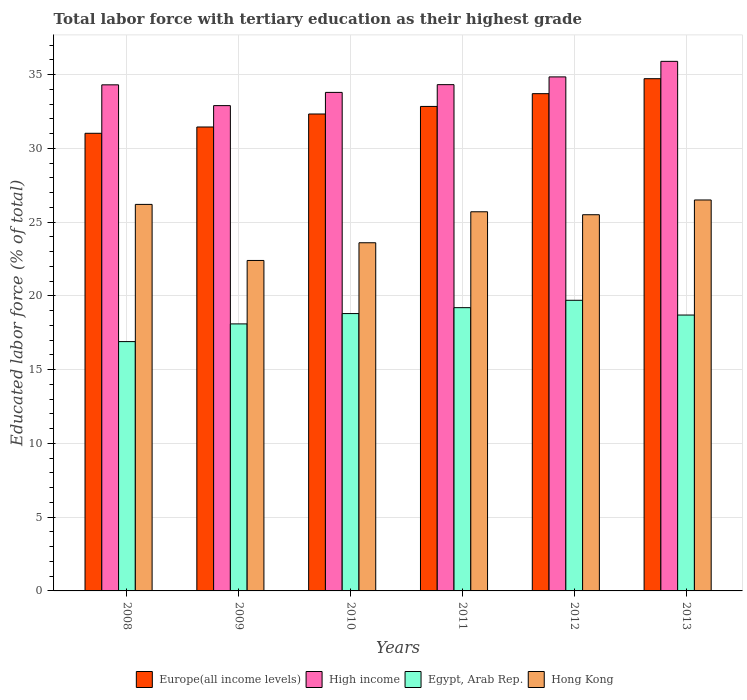How many groups of bars are there?
Offer a terse response. 6. Are the number of bars on each tick of the X-axis equal?
Ensure brevity in your answer.  Yes. What is the label of the 2nd group of bars from the left?
Ensure brevity in your answer.  2009. In how many cases, is the number of bars for a given year not equal to the number of legend labels?
Your answer should be very brief. 0. What is the percentage of male labor force with tertiary education in High income in 2012?
Provide a succinct answer. 34.84. Across all years, what is the maximum percentage of male labor force with tertiary education in Hong Kong?
Provide a short and direct response. 26.5. Across all years, what is the minimum percentage of male labor force with tertiary education in High income?
Your response must be concise. 32.9. In which year was the percentage of male labor force with tertiary education in Hong Kong minimum?
Keep it short and to the point. 2009. What is the total percentage of male labor force with tertiary education in Europe(all income levels) in the graph?
Give a very brief answer. 196.06. What is the difference between the percentage of male labor force with tertiary education in Europe(all income levels) in 2009 and that in 2010?
Provide a short and direct response. -0.88. What is the difference between the percentage of male labor force with tertiary education in High income in 2011 and the percentage of male labor force with tertiary education in Egypt, Arab Rep. in 2008?
Your answer should be very brief. 17.42. What is the average percentage of male labor force with tertiary education in High income per year?
Provide a short and direct response. 34.34. In the year 2011, what is the difference between the percentage of male labor force with tertiary education in Hong Kong and percentage of male labor force with tertiary education in Egypt, Arab Rep.?
Keep it short and to the point. 6.5. What is the ratio of the percentage of male labor force with tertiary education in Europe(all income levels) in 2009 to that in 2011?
Provide a succinct answer. 0.96. Is the percentage of male labor force with tertiary education in Europe(all income levels) in 2009 less than that in 2010?
Offer a terse response. Yes. What is the difference between the highest and the second highest percentage of male labor force with tertiary education in High income?
Your response must be concise. 1.05. What is the difference between the highest and the lowest percentage of male labor force with tertiary education in Egypt, Arab Rep.?
Offer a terse response. 2.8. Is the sum of the percentage of male labor force with tertiary education in Hong Kong in 2009 and 2012 greater than the maximum percentage of male labor force with tertiary education in Egypt, Arab Rep. across all years?
Make the answer very short. Yes. Is it the case that in every year, the sum of the percentage of male labor force with tertiary education in Hong Kong and percentage of male labor force with tertiary education in Europe(all income levels) is greater than the sum of percentage of male labor force with tertiary education in Egypt, Arab Rep. and percentage of male labor force with tertiary education in High income?
Your answer should be compact. Yes. What does the 1st bar from the left in 2012 represents?
Keep it short and to the point. Europe(all income levels). What does the 2nd bar from the right in 2008 represents?
Offer a terse response. Egypt, Arab Rep. Is it the case that in every year, the sum of the percentage of male labor force with tertiary education in Egypt, Arab Rep. and percentage of male labor force with tertiary education in High income is greater than the percentage of male labor force with tertiary education in Hong Kong?
Give a very brief answer. Yes. Are all the bars in the graph horizontal?
Keep it short and to the point. No. What is the difference between two consecutive major ticks on the Y-axis?
Your response must be concise. 5. Are the values on the major ticks of Y-axis written in scientific E-notation?
Your answer should be very brief. No. Does the graph contain any zero values?
Give a very brief answer. No. Does the graph contain grids?
Give a very brief answer. Yes. What is the title of the graph?
Keep it short and to the point. Total labor force with tertiary education as their highest grade. What is the label or title of the X-axis?
Provide a short and direct response. Years. What is the label or title of the Y-axis?
Keep it short and to the point. Educated labor force (% of total). What is the Educated labor force (% of total) in Europe(all income levels) in 2008?
Keep it short and to the point. 31.02. What is the Educated labor force (% of total) of High income in 2008?
Make the answer very short. 34.3. What is the Educated labor force (% of total) in Egypt, Arab Rep. in 2008?
Your response must be concise. 16.9. What is the Educated labor force (% of total) of Hong Kong in 2008?
Your response must be concise. 26.2. What is the Educated labor force (% of total) in Europe(all income levels) in 2009?
Make the answer very short. 31.45. What is the Educated labor force (% of total) of High income in 2009?
Your response must be concise. 32.9. What is the Educated labor force (% of total) in Egypt, Arab Rep. in 2009?
Your answer should be very brief. 18.1. What is the Educated labor force (% of total) in Hong Kong in 2009?
Provide a short and direct response. 22.4. What is the Educated labor force (% of total) in Europe(all income levels) in 2010?
Your answer should be compact. 32.33. What is the Educated labor force (% of total) of High income in 2010?
Offer a very short reply. 33.79. What is the Educated labor force (% of total) of Egypt, Arab Rep. in 2010?
Your answer should be compact. 18.8. What is the Educated labor force (% of total) in Hong Kong in 2010?
Provide a succinct answer. 23.6. What is the Educated labor force (% of total) in Europe(all income levels) in 2011?
Provide a short and direct response. 32.84. What is the Educated labor force (% of total) in High income in 2011?
Offer a very short reply. 34.32. What is the Educated labor force (% of total) in Egypt, Arab Rep. in 2011?
Your answer should be very brief. 19.2. What is the Educated labor force (% of total) of Hong Kong in 2011?
Give a very brief answer. 25.7. What is the Educated labor force (% of total) in Europe(all income levels) in 2012?
Offer a terse response. 33.71. What is the Educated labor force (% of total) in High income in 2012?
Your answer should be very brief. 34.84. What is the Educated labor force (% of total) of Egypt, Arab Rep. in 2012?
Offer a very short reply. 19.7. What is the Educated labor force (% of total) of Hong Kong in 2012?
Ensure brevity in your answer.  25.5. What is the Educated labor force (% of total) of Europe(all income levels) in 2013?
Ensure brevity in your answer.  34.72. What is the Educated labor force (% of total) of High income in 2013?
Provide a short and direct response. 35.9. What is the Educated labor force (% of total) in Egypt, Arab Rep. in 2013?
Keep it short and to the point. 18.7. What is the Educated labor force (% of total) in Hong Kong in 2013?
Make the answer very short. 26.5. Across all years, what is the maximum Educated labor force (% of total) of Europe(all income levels)?
Your answer should be compact. 34.72. Across all years, what is the maximum Educated labor force (% of total) in High income?
Provide a succinct answer. 35.9. Across all years, what is the maximum Educated labor force (% of total) in Egypt, Arab Rep.?
Give a very brief answer. 19.7. Across all years, what is the maximum Educated labor force (% of total) of Hong Kong?
Offer a very short reply. 26.5. Across all years, what is the minimum Educated labor force (% of total) of Europe(all income levels)?
Ensure brevity in your answer.  31.02. Across all years, what is the minimum Educated labor force (% of total) of High income?
Offer a very short reply. 32.9. Across all years, what is the minimum Educated labor force (% of total) of Egypt, Arab Rep.?
Give a very brief answer. 16.9. Across all years, what is the minimum Educated labor force (% of total) of Hong Kong?
Make the answer very short. 22.4. What is the total Educated labor force (% of total) of Europe(all income levels) in the graph?
Ensure brevity in your answer.  196.06. What is the total Educated labor force (% of total) in High income in the graph?
Your response must be concise. 206.05. What is the total Educated labor force (% of total) in Egypt, Arab Rep. in the graph?
Your answer should be compact. 111.4. What is the total Educated labor force (% of total) of Hong Kong in the graph?
Provide a succinct answer. 149.9. What is the difference between the Educated labor force (% of total) in Europe(all income levels) in 2008 and that in 2009?
Keep it short and to the point. -0.43. What is the difference between the Educated labor force (% of total) in High income in 2008 and that in 2009?
Your response must be concise. 1.41. What is the difference between the Educated labor force (% of total) of Hong Kong in 2008 and that in 2009?
Offer a very short reply. 3.8. What is the difference between the Educated labor force (% of total) of Europe(all income levels) in 2008 and that in 2010?
Make the answer very short. -1.31. What is the difference between the Educated labor force (% of total) in High income in 2008 and that in 2010?
Make the answer very short. 0.51. What is the difference between the Educated labor force (% of total) of Egypt, Arab Rep. in 2008 and that in 2010?
Your answer should be compact. -1.9. What is the difference between the Educated labor force (% of total) of Hong Kong in 2008 and that in 2010?
Keep it short and to the point. 2.6. What is the difference between the Educated labor force (% of total) in Europe(all income levels) in 2008 and that in 2011?
Keep it short and to the point. -1.82. What is the difference between the Educated labor force (% of total) in High income in 2008 and that in 2011?
Provide a short and direct response. -0.01. What is the difference between the Educated labor force (% of total) in Egypt, Arab Rep. in 2008 and that in 2011?
Your answer should be compact. -2.3. What is the difference between the Educated labor force (% of total) of Hong Kong in 2008 and that in 2011?
Your answer should be compact. 0.5. What is the difference between the Educated labor force (% of total) in Europe(all income levels) in 2008 and that in 2012?
Your response must be concise. -2.69. What is the difference between the Educated labor force (% of total) in High income in 2008 and that in 2012?
Your answer should be compact. -0.54. What is the difference between the Educated labor force (% of total) of Egypt, Arab Rep. in 2008 and that in 2012?
Ensure brevity in your answer.  -2.8. What is the difference between the Educated labor force (% of total) of Hong Kong in 2008 and that in 2012?
Provide a short and direct response. 0.7. What is the difference between the Educated labor force (% of total) of Europe(all income levels) in 2008 and that in 2013?
Your response must be concise. -3.7. What is the difference between the Educated labor force (% of total) in High income in 2008 and that in 2013?
Give a very brief answer. -1.59. What is the difference between the Educated labor force (% of total) of Europe(all income levels) in 2009 and that in 2010?
Keep it short and to the point. -0.88. What is the difference between the Educated labor force (% of total) in High income in 2009 and that in 2010?
Your answer should be very brief. -0.9. What is the difference between the Educated labor force (% of total) of Egypt, Arab Rep. in 2009 and that in 2010?
Give a very brief answer. -0.7. What is the difference between the Educated labor force (% of total) in Hong Kong in 2009 and that in 2010?
Your answer should be compact. -1.2. What is the difference between the Educated labor force (% of total) in Europe(all income levels) in 2009 and that in 2011?
Ensure brevity in your answer.  -1.39. What is the difference between the Educated labor force (% of total) in High income in 2009 and that in 2011?
Your answer should be very brief. -1.42. What is the difference between the Educated labor force (% of total) of Egypt, Arab Rep. in 2009 and that in 2011?
Offer a terse response. -1.1. What is the difference between the Educated labor force (% of total) in Hong Kong in 2009 and that in 2011?
Your response must be concise. -3.3. What is the difference between the Educated labor force (% of total) in Europe(all income levels) in 2009 and that in 2012?
Provide a succinct answer. -2.26. What is the difference between the Educated labor force (% of total) in High income in 2009 and that in 2012?
Ensure brevity in your answer.  -1.95. What is the difference between the Educated labor force (% of total) in Egypt, Arab Rep. in 2009 and that in 2012?
Ensure brevity in your answer.  -1.6. What is the difference between the Educated labor force (% of total) in Europe(all income levels) in 2009 and that in 2013?
Ensure brevity in your answer.  -3.27. What is the difference between the Educated labor force (% of total) in High income in 2009 and that in 2013?
Your answer should be compact. -3. What is the difference between the Educated labor force (% of total) of Hong Kong in 2009 and that in 2013?
Make the answer very short. -4.1. What is the difference between the Educated labor force (% of total) of Europe(all income levels) in 2010 and that in 2011?
Give a very brief answer. -0.51. What is the difference between the Educated labor force (% of total) in High income in 2010 and that in 2011?
Your answer should be compact. -0.52. What is the difference between the Educated labor force (% of total) of Egypt, Arab Rep. in 2010 and that in 2011?
Your answer should be very brief. -0.4. What is the difference between the Educated labor force (% of total) in Europe(all income levels) in 2010 and that in 2012?
Provide a succinct answer. -1.38. What is the difference between the Educated labor force (% of total) in High income in 2010 and that in 2012?
Provide a short and direct response. -1.05. What is the difference between the Educated labor force (% of total) in Europe(all income levels) in 2010 and that in 2013?
Your answer should be very brief. -2.39. What is the difference between the Educated labor force (% of total) in High income in 2010 and that in 2013?
Keep it short and to the point. -2.1. What is the difference between the Educated labor force (% of total) of Egypt, Arab Rep. in 2010 and that in 2013?
Provide a succinct answer. 0.1. What is the difference between the Educated labor force (% of total) in Hong Kong in 2010 and that in 2013?
Your answer should be compact. -2.9. What is the difference between the Educated labor force (% of total) in Europe(all income levels) in 2011 and that in 2012?
Your answer should be compact. -0.87. What is the difference between the Educated labor force (% of total) of High income in 2011 and that in 2012?
Offer a terse response. -0.53. What is the difference between the Educated labor force (% of total) of Egypt, Arab Rep. in 2011 and that in 2012?
Keep it short and to the point. -0.5. What is the difference between the Educated labor force (% of total) of Hong Kong in 2011 and that in 2012?
Your answer should be compact. 0.2. What is the difference between the Educated labor force (% of total) of Europe(all income levels) in 2011 and that in 2013?
Give a very brief answer. -1.88. What is the difference between the Educated labor force (% of total) in High income in 2011 and that in 2013?
Provide a short and direct response. -1.58. What is the difference between the Educated labor force (% of total) of Hong Kong in 2011 and that in 2013?
Give a very brief answer. -0.8. What is the difference between the Educated labor force (% of total) in Europe(all income levels) in 2012 and that in 2013?
Keep it short and to the point. -1.01. What is the difference between the Educated labor force (% of total) of High income in 2012 and that in 2013?
Keep it short and to the point. -1.05. What is the difference between the Educated labor force (% of total) of Egypt, Arab Rep. in 2012 and that in 2013?
Provide a short and direct response. 1. What is the difference between the Educated labor force (% of total) of Hong Kong in 2012 and that in 2013?
Offer a very short reply. -1. What is the difference between the Educated labor force (% of total) of Europe(all income levels) in 2008 and the Educated labor force (% of total) of High income in 2009?
Provide a succinct answer. -1.88. What is the difference between the Educated labor force (% of total) in Europe(all income levels) in 2008 and the Educated labor force (% of total) in Egypt, Arab Rep. in 2009?
Keep it short and to the point. 12.92. What is the difference between the Educated labor force (% of total) of Europe(all income levels) in 2008 and the Educated labor force (% of total) of Hong Kong in 2009?
Make the answer very short. 8.62. What is the difference between the Educated labor force (% of total) of High income in 2008 and the Educated labor force (% of total) of Egypt, Arab Rep. in 2009?
Your response must be concise. 16.2. What is the difference between the Educated labor force (% of total) of High income in 2008 and the Educated labor force (% of total) of Hong Kong in 2009?
Your answer should be compact. 11.9. What is the difference between the Educated labor force (% of total) in Europe(all income levels) in 2008 and the Educated labor force (% of total) in High income in 2010?
Provide a short and direct response. -2.77. What is the difference between the Educated labor force (% of total) of Europe(all income levels) in 2008 and the Educated labor force (% of total) of Egypt, Arab Rep. in 2010?
Keep it short and to the point. 12.22. What is the difference between the Educated labor force (% of total) in Europe(all income levels) in 2008 and the Educated labor force (% of total) in Hong Kong in 2010?
Offer a terse response. 7.42. What is the difference between the Educated labor force (% of total) of High income in 2008 and the Educated labor force (% of total) of Egypt, Arab Rep. in 2010?
Make the answer very short. 15.5. What is the difference between the Educated labor force (% of total) in High income in 2008 and the Educated labor force (% of total) in Hong Kong in 2010?
Your answer should be compact. 10.7. What is the difference between the Educated labor force (% of total) of Egypt, Arab Rep. in 2008 and the Educated labor force (% of total) of Hong Kong in 2010?
Offer a terse response. -6.7. What is the difference between the Educated labor force (% of total) of Europe(all income levels) in 2008 and the Educated labor force (% of total) of High income in 2011?
Give a very brief answer. -3.3. What is the difference between the Educated labor force (% of total) of Europe(all income levels) in 2008 and the Educated labor force (% of total) of Egypt, Arab Rep. in 2011?
Your answer should be very brief. 11.82. What is the difference between the Educated labor force (% of total) of Europe(all income levels) in 2008 and the Educated labor force (% of total) of Hong Kong in 2011?
Your answer should be compact. 5.32. What is the difference between the Educated labor force (% of total) in High income in 2008 and the Educated labor force (% of total) in Egypt, Arab Rep. in 2011?
Give a very brief answer. 15.1. What is the difference between the Educated labor force (% of total) of High income in 2008 and the Educated labor force (% of total) of Hong Kong in 2011?
Ensure brevity in your answer.  8.6. What is the difference between the Educated labor force (% of total) of Europe(all income levels) in 2008 and the Educated labor force (% of total) of High income in 2012?
Ensure brevity in your answer.  -3.82. What is the difference between the Educated labor force (% of total) in Europe(all income levels) in 2008 and the Educated labor force (% of total) in Egypt, Arab Rep. in 2012?
Your answer should be very brief. 11.32. What is the difference between the Educated labor force (% of total) of Europe(all income levels) in 2008 and the Educated labor force (% of total) of Hong Kong in 2012?
Your answer should be compact. 5.52. What is the difference between the Educated labor force (% of total) in High income in 2008 and the Educated labor force (% of total) in Egypt, Arab Rep. in 2012?
Offer a very short reply. 14.6. What is the difference between the Educated labor force (% of total) of High income in 2008 and the Educated labor force (% of total) of Hong Kong in 2012?
Your answer should be very brief. 8.8. What is the difference between the Educated labor force (% of total) in Egypt, Arab Rep. in 2008 and the Educated labor force (% of total) in Hong Kong in 2012?
Your response must be concise. -8.6. What is the difference between the Educated labor force (% of total) of Europe(all income levels) in 2008 and the Educated labor force (% of total) of High income in 2013?
Keep it short and to the point. -4.88. What is the difference between the Educated labor force (% of total) of Europe(all income levels) in 2008 and the Educated labor force (% of total) of Egypt, Arab Rep. in 2013?
Provide a short and direct response. 12.32. What is the difference between the Educated labor force (% of total) of Europe(all income levels) in 2008 and the Educated labor force (% of total) of Hong Kong in 2013?
Offer a terse response. 4.52. What is the difference between the Educated labor force (% of total) in High income in 2008 and the Educated labor force (% of total) in Egypt, Arab Rep. in 2013?
Your response must be concise. 15.6. What is the difference between the Educated labor force (% of total) of High income in 2008 and the Educated labor force (% of total) of Hong Kong in 2013?
Ensure brevity in your answer.  7.8. What is the difference between the Educated labor force (% of total) in Egypt, Arab Rep. in 2008 and the Educated labor force (% of total) in Hong Kong in 2013?
Offer a very short reply. -9.6. What is the difference between the Educated labor force (% of total) of Europe(all income levels) in 2009 and the Educated labor force (% of total) of High income in 2010?
Provide a succinct answer. -2.35. What is the difference between the Educated labor force (% of total) in Europe(all income levels) in 2009 and the Educated labor force (% of total) in Egypt, Arab Rep. in 2010?
Offer a terse response. 12.65. What is the difference between the Educated labor force (% of total) in Europe(all income levels) in 2009 and the Educated labor force (% of total) in Hong Kong in 2010?
Offer a very short reply. 7.85. What is the difference between the Educated labor force (% of total) in High income in 2009 and the Educated labor force (% of total) in Egypt, Arab Rep. in 2010?
Your answer should be very brief. 14.1. What is the difference between the Educated labor force (% of total) in High income in 2009 and the Educated labor force (% of total) in Hong Kong in 2010?
Provide a short and direct response. 9.3. What is the difference between the Educated labor force (% of total) of Europe(all income levels) in 2009 and the Educated labor force (% of total) of High income in 2011?
Ensure brevity in your answer.  -2.87. What is the difference between the Educated labor force (% of total) in Europe(all income levels) in 2009 and the Educated labor force (% of total) in Egypt, Arab Rep. in 2011?
Your answer should be compact. 12.25. What is the difference between the Educated labor force (% of total) of Europe(all income levels) in 2009 and the Educated labor force (% of total) of Hong Kong in 2011?
Offer a very short reply. 5.75. What is the difference between the Educated labor force (% of total) of High income in 2009 and the Educated labor force (% of total) of Egypt, Arab Rep. in 2011?
Offer a terse response. 13.7. What is the difference between the Educated labor force (% of total) of High income in 2009 and the Educated labor force (% of total) of Hong Kong in 2011?
Keep it short and to the point. 7.2. What is the difference between the Educated labor force (% of total) of Egypt, Arab Rep. in 2009 and the Educated labor force (% of total) of Hong Kong in 2011?
Offer a very short reply. -7.6. What is the difference between the Educated labor force (% of total) of Europe(all income levels) in 2009 and the Educated labor force (% of total) of High income in 2012?
Offer a terse response. -3.4. What is the difference between the Educated labor force (% of total) in Europe(all income levels) in 2009 and the Educated labor force (% of total) in Egypt, Arab Rep. in 2012?
Keep it short and to the point. 11.75. What is the difference between the Educated labor force (% of total) in Europe(all income levels) in 2009 and the Educated labor force (% of total) in Hong Kong in 2012?
Your answer should be very brief. 5.95. What is the difference between the Educated labor force (% of total) of High income in 2009 and the Educated labor force (% of total) of Egypt, Arab Rep. in 2012?
Your answer should be very brief. 13.2. What is the difference between the Educated labor force (% of total) of High income in 2009 and the Educated labor force (% of total) of Hong Kong in 2012?
Your answer should be very brief. 7.4. What is the difference between the Educated labor force (% of total) of Europe(all income levels) in 2009 and the Educated labor force (% of total) of High income in 2013?
Your answer should be very brief. -4.45. What is the difference between the Educated labor force (% of total) of Europe(all income levels) in 2009 and the Educated labor force (% of total) of Egypt, Arab Rep. in 2013?
Your answer should be very brief. 12.75. What is the difference between the Educated labor force (% of total) in Europe(all income levels) in 2009 and the Educated labor force (% of total) in Hong Kong in 2013?
Provide a short and direct response. 4.95. What is the difference between the Educated labor force (% of total) in High income in 2009 and the Educated labor force (% of total) in Egypt, Arab Rep. in 2013?
Provide a short and direct response. 14.2. What is the difference between the Educated labor force (% of total) of High income in 2009 and the Educated labor force (% of total) of Hong Kong in 2013?
Your response must be concise. 6.4. What is the difference between the Educated labor force (% of total) of Europe(all income levels) in 2010 and the Educated labor force (% of total) of High income in 2011?
Ensure brevity in your answer.  -1.99. What is the difference between the Educated labor force (% of total) in Europe(all income levels) in 2010 and the Educated labor force (% of total) in Egypt, Arab Rep. in 2011?
Ensure brevity in your answer.  13.13. What is the difference between the Educated labor force (% of total) of Europe(all income levels) in 2010 and the Educated labor force (% of total) of Hong Kong in 2011?
Offer a terse response. 6.63. What is the difference between the Educated labor force (% of total) in High income in 2010 and the Educated labor force (% of total) in Egypt, Arab Rep. in 2011?
Give a very brief answer. 14.59. What is the difference between the Educated labor force (% of total) of High income in 2010 and the Educated labor force (% of total) of Hong Kong in 2011?
Your response must be concise. 8.09. What is the difference between the Educated labor force (% of total) in Europe(all income levels) in 2010 and the Educated labor force (% of total) in High income in 2012?
Offer a very short reply. -2.51. What is the difference between the Educated labor force (% of total) in Europe(all income levels) in 2010 and the Educated labor force (% of total) in Egypt, Arab Rep. in 2012?
Keep it short and to the point. 12.63. What is the difference between the Educated labor force (% of total) in Europe(all income levels) in 2010 and the Educated labor force (% of total) in Hong Kong in 2012?
Make the answer very short. 6.83. What is the difference between the Educated labor force (% of total) in High income in 2010 and the Educated labor force (% of total) in Egypt, Arab Rep. in 2012?
Your answer should be very brief. 14.09. What is the difference between the Educated labor force (% of total) in High income in 2010 and the Educated labor force (% of total) in Hong Kong in 2012?
Give a very brief answer. 8.29. What is the difference between the Educated labor force (% of total) in Europe(all income levels) in 2010 and the Educated labor force (% of total) in High income in 2013?
Provide a succinct answer. -3.57. What is the difference between the Educated labor force (% of total) of Europe(all income levels) in 2010 and the Educated labor force (% of total) of Egypt, Arab Rep. in 2013?
Your answer should be very brief. 13.63. What is the difference between the Educated labor force (% of total) in Europe(all income levels) in 2010 and the Educated labor force (% of total) in Hong Kong in 2013?
Provide a short and direct response. 5.83. What is the difference between the Educated labor force (% of total) of High income in 2010 and the Educated labor force (% of total) of Egypt, Arab Rep. in 2013?
Ensure brevity in your answer.  15.09. What is the difference between the Educated labor force (% of total) of High income in 2010 and the Educated labor force (% of total) of Hong Kong in 2013?
Provide a short and direct response. 7.29. What is the difference between the Educated labor force (% of total) in Europe(all income levels) in 2011 and the Educated labor force (% of total) in High income in 2012?
Your answer should be compact. -2. What is the difference between the Educated labor force (% of total) of Europe(all income levels) in 2011 and the Educated labor force (% of total) of Egypt, Arab Rep. in 2012?
Provide a succinct answer. 13.14. What is the difference between the Educated labor force (% of total) of Europe(all income levels) in 2011 and the Educated labor force (% of total) of Hong Kong in 2012?
Make the answer very short. 7.34. What is the difference between the Educated labor force (% of total) in High income in 2011 and the Educated labor force (% of total) in Egypt, Arab Rep. in 2012?
Give a very brief answer. 14.62. What is the difference between the Educated labor force (% of total) in High income in 2011 and the Educated labor force (% of total) in Hong Kong in 2012?
Provide a succinct answer. 8.82. What is the difference between the Educated labor force (% of total) of Egypt, Arab Rep. in 2011 and the Educated labor force (% of total) of Hong Kong in 2012?
Keep it short and to the point. -6.3. What is the difference between the Educated labor force (% of total) in Europe(all income levels) in 2011 and the Educated labor force (% of total) in High income in 2013?
Keep it short and to the point. -3.06. What is the difference between the Educated labor force (% of total) of Europe(all income levels) in 2011 and the Educated labor force (% of total) of Egypt, Arab Rep. in 2013?
Offer a very short reply. 14.14. What is the difference between the Educated labor force (% of total) in Europe(all income levels) in 2011 and the Educated labor force (% of total) in Hong Kong in 2013?
Provide a short and direct response. 6.34. What is the difference between the Educated labor force (% of total) in High income in 2011 and the Educated labor force (% of total) in Egypt, Arab Rep. in 2013?
Your response must be concise. 15.62. What is the difference between the Educated labor force (% of total) in High income in 2011 and the Educated labor force (% of total) in Hong Kong in 2013?
Your answer should be very brief. 7.82. What is the difference between the Educated labor force (% of total) of Egypt, Arab Rep. in 2011 and the Educated labor force (% of total) of Hong Kong in 2013?
Offer a terse response. -7.3. What is the difference between the Educated labor force (% of total) of Europe(all income levels) in 2012 and the Educated labor force (% of total) of High income in 2013?
Offer a very short reply. -2.19. What is the difference between the Educated labor force (% of total) of Europe(all income levels) in 2012 and the Educated labor force (% of total) of Egypt, Arab Rep. in 2013?
Your answer should be very brief. 15.01. What is the difference between the Educated labor force (% of total) in Europe(all income levels) in 2012 and the Educated labor force (% of total) in Hong Kong in 2013?
Your answer should be compact. 7.21. What is the difference between the Educated labor force (% of total) in High income in 2012 and the Educated labor force (% of total) in Egypt, Arab Rep. in 2013?
Your answer should be compact. 16.14. What is the difference between the Educated labor force (% of total) in High income in 2012 and the Educated labor force (% of total) in Hong Kong in 2013?
Give a very brief answer. 8.34. What is the average Educated labor force (% of total) of Europe(all income levels) per year?
Provide a short and direct response. 32.68. What is the average Educated labor force (% of total) in High income per year?
Keep it short and to the point. 34.34. What is the average Educated labor force (% of total) of Egypt, Arab Rep. per year?
Offer a terse response. 18.57. What is the average Educated labor force (% of total) of Hong Kong per year?
Provide a succinct answer. 24.98. In the year 2008, what is the difference between the Educated labor force (% of total) of Europe(all income levels) and Educated labor force (% of total) of High income?
Keep it short and to the point. -3.28. In the year 2008, what is the difference between the Educated labor force (% of total) in Europe(all income levels) and Educated labor force (% of total) in Egypt, Arab Rep.?
Provide a short and direct response. 14.12. In the year 2008, what is the difference between the Educated labor force (% of total) in Europe(all income levels) and Educated labor force (% of total) in Hong Kong?
Ensure brevity in your answer.  4.82. In the year 2008, what is the difference between the Educated labor force (% of total) in High income and Educated labor force (% of total) in Egypt, Arab Rep.?
Keep it short and to the point. 17.4. In the year 2008, what is the difference between the Educated labor force (% of total) of High income and Educated labor force (% of total) of Hong Kong?
Provide a succinct answer. 8.1. In the year 2009, what is the difference between the Educated labor force (% of total) of Europe(all income levels) and Educated labor force (% of total) of High income?
Keep it short and to the point. -1.45. In the year 2009, what is the difference between the Educated labor force (% of total) of Europe(all income levels) and Educated labor force (% of total) of Egypt, Arab Rep.?
Keep it short and to the point. 13.35. In the year 2009, what is the difference between the Educated labor force (% of total) in Europe(all income levels) and Educated labor force (% of total) in Hong Kong?
Offer a very short reply. 9.05. In the year 2009, what is the difference between the Educated labor force (% of total) of High income and Educated labor force (% of total) of Egypt, Arab Rep.?
Your answer should be compact. 14.8. In the year 2009, what is the difference between the Educated labor force (% of total) in High income and Educated labor force (% of total) in Hong Kong?
Make the answer very short. 10.5. In the year 2009, what is the difference between the Educated labor force (% of total) of Egypt, Arab Rep. and Educated labor force (% of total) of Hong Kong?
Provide a short and direct response. -4.3. In the year 2010, what is the difference between the Educated labor force (% of total) of Europe(all income levels) and Educated labor force (% of total) of High income?
Keep it short and to the point. -1.46. In the year 2010, what is the difference between the Educated labor force (% of total) in Europe(all income levels) and Educated labor force (% of total) in Egypt, Arab Rep.?
Provide a succinct answer. 13.53. In the year 2010, what is the difference between the Educated labor force (% of total) in Europe(all income levels) and Educated labor force (% of total) in Hong Kong?
Keep it short and to the point. 8.73. In the year 2010, what is the difference between the Educated labor force (% of total) in High income and Educated labor force (% of total) in Egypt, Arab Rep.?
Provide a short and direct response. 14.99. In the year 2010, what is the difference between the Educated labor force (% of total) of High income and Educated labor force (% of total) of Hong Kong?
Your answer should be compact. 10.19. In the year 2010, what is the difference between the Educated labor force (% of total) of Egypt, Arab Rep. and Educated labor force (% of total) of Hong Kong?
Your response must be concise. -4.8. In the year 2011, what is the difference between the Educated labor force (% of total) in Europe(all income levels) and Educated labor force (% of total) in High income?
Provide a short and direct response. -1.48. In the year 2011, what is the difference between the Educated labor force (% of total) of Europe(all income levels) and Educated labor force (% of total) of Egypt, Arab Rep.?
Keep it short and to the point. 13.64. In the year 2011, what is the difference between the Educated labor force (% of total) in Europe(all income levels) and Educated labor force (% of total) in Hong Kong?
Make the answer very short. 7.14. In the year 2011, what is the difference between the Educated labor force (% of total) in High income and Educated labor force (% of total) in Egypt, Arab Rep.?
Provide a short and direct response. 15.12. In the year 2011, what is the difference between the Educated labor force (% of total) in High income and Educated labor force (% of total) in Hong Kong?
Your answer should be very brief. 8.62. In the year 2012, what is the difference between the Educated labor force (% of total) of Europe(all income levels) and Educated labor force (% of total) of High income?
Give a very brief answer. -1.14. In the year 2012, what is the difference between the Educated labor force (% of total) of Europe(all income levels) and Educated labor force (% of total) of Egypt, Arab Rep.?
Provide a short and direct response. 14.01. In the year 2012, what is the difference between the Educated labor force (% of total) in Europe(all income levels) and Educated labor force (% of total) in Hong Kong?
Ensure brevity in your answer.  8.21. In the year 2012, what is the difference between the Educated labor force (% of total) in High income and Educated labor force (% of total) in Egypt, Arab Rep.?
Offer a very short reply. 15.14. In the year 2012, what is the difference between the Educated labor force (% of total) of High income and Educated labor force (% of total) of Hong Kong?
Your response must be concise. 9.34. In the year 2013, what is the difference between the Educated labor force (% of total) in Europe(all income levels) and Educated labor force (% of total) in High income?
Offer a terse response. -1.18. In the year 2013, what is the difference between the Educated labor force (% of total) in Europe(all income levels) and Educated labor force (% of total) in Egypt, Arab Rep.?
Keep it short and to the point. 16.02. In the year 2013, what is the difference between the Educated labor force (% of total) in Europe(all income levels) and Educated labor force (% of total) in Hong Kong?
Keep it short and to the point. 8.22. In the year 2013, what is the difference between the Educated labor force (% of total) of High income and Educated labor force (% of total) of Egypt, Arab Rep.?
Give a very brief answer. 17.2. In the year 2013, what is the difference between the Educated labor force (% of total) in High income and Educated labor force (% of total) in Hong Kong?
Offer a very short reply. 9.4. In the year 2013, what is the difference between the Educated labor force (% of total) of Egypt, Arab Rep. and Educated labor force (% of total) of Hong Kong?
Provide a short and direct response. -7.8. What is the ratio of the Educated labor force (% of total) of Europe(all income levels) in 2008 to that in 2009?
Make the answer very short. 0.99. What is the ratio of the Educated labor force (% of total) of High income in 2008 to that in 2009?
Offer a very short reply. 1.04. What is the ratio of the Educated labor force (% of total) of Egypt, Arab Rep. in 2008 to that in 2009?
Keep it short and to the point. 0.93. What is the ratio of the Educated labor force (% of total) in Hong Kong in 2008 to that in 2009?
Provide a succinct answer. 1.17. What is the ratio of the Educated labor force (% of total) in Europe(all income levels) in 2008 to that in 2010?
Make the answer very short. 0.96. What is the ratio of the Educated labor force (% of total) of High income in 2008 to that in 2010?
Your response must be concise. 1.02. What is the ratio of the Educated labor force (% of total) in Egypt, Arab Rep. in 2008 to that in 2010?
Your response must be concise. 0.9. What is the ratio of the Educated labor force (% of total) in Hong Kong in 2008 to that in 2010?
Your answer should be very brief. 1.11. What is the ratio of the Educated labor force (% of total) in Europe(all income levels) in 2008 to that in 2011?
Your answer should be very brief. 0.94. What is the ratio of the Educated labor force (% of total) in High income in 2008 to that in 2011?
Provide a short and direct response. 1. What is the ratio of the Educated labor force (% of total) in Egypt, Arab Rep. in 2008 to that in 2011?
Your answer should be very brief. 0.88. What is the ratio of the Educated labor force (% of total) in Hong Kong in 2008 to that in 2011?
Offer a terse response. 1.02. What is the ratio of the Educated labor force (% of total) in Europe(all income levels) in 2008 to that in 2012?
Your answer should be very brief. 0.92. What is the ratio of the Educated labor force (% of total) in High income in 2008 to that in 2012?
Your response must be concise. 0.98. What is the ratio of the Educated labor force (% of total) of Egypt, Arab Rep. in 2008 to that in 2012?
Make the answer very short. 0.86. What is the ratio of the Educated labor force (% of total) of Hong Kong in 2008 to that in 2012?
Provide a short and direct response. 1.03. What is the ratio of the Educated labor force (% of total) of Europe(all income levels) in 2008 to that in 2013?
Provide a short and direct response. 0.89. What is the ratio of the Educated labor force (% of total) of High income in 2008 to that in 2013?
Make the answer very short. 0.96. What is the ratio of the Educated labor force (% of total) in Egypt, Arab Rep. in 2008 to that in 2013?
Provide a short and direct response. 0.9. What is the ratio of the Educated labor force (% of total) in Hong Kong in 2008 to that in 2013?
Your response must be concise. 0.99. What is the ratio of the Educated labor force (% of total) in Europe(all income levels) in 2009 to that in 2010?
Offer a terse response. 0.97. What is the ratio of the Educated labor force (% of total) of High income in 2009 to that in 2010?
Your answer should be compact. 0.97. What is the ratio of the Educated labor force (% of total) in Egypt, Arab Rep. in 2009 to that in 2010?
Your answer should be very brief. 0.96. What is the ratio of the Educated labor force (% of total) of Hong Kong in 2009 to that in 2010?
Give a very brief answer. 0.95. What is the ratio of the Educated labor force (% of total) of Europe(all income levels) in 2009 to that in 2011?
Ensure brevity in your answer.  0.96. What is the ratio of the Educated labor force (% of total) of High income in 2009 to that in 2011?
Make the answer very short. 0.96. What is the ratio of the Educated labor force (% of total) of Egypt, Arab Rep. in 2009 to that in 2011?
Your answer should be very brief. 0.94. What is the ratio of the Educated labor force (% of total) in Hong Kong in 2009 to that in 2011?
Your answer should be compact. 0.87. What is the ratio of the Educated labor force (% of total) of Europe(all income levels) in 2009 to that in 2012?
Provide a short and direct response. 0.93. What is the ratio of the Educated labor force (% of total) in High income in 2009 to that in 2012?
Provide a short and direct response. 0.94. What is the ratio of the Educated labor force (% of total) in Egypt, Arab Rep. in 2009 to that in 2012?
Offer a very short reply. 0.92. What is the ratio of the Educated labor force (% of total) in Hong Kong in 2009 to that in 2012?
Ensure brevity in your answer.  0.88. What is the ratio of the Educated labor force (% of total) in Europe(all income levels) in 2009 to that in 2013?
Offer a very short reply. 0.91. What is the ratio of the Educated labor force (% of total) of High income in 2009 to that in 2013?
Offer a very short reply. 0.92. What is the ratio of the Educated labor force (% of total) in Egypt, Arab Rep. in 2009 to that in 2013?
Provide a succinct answer. 0.97. What is the ratio of the Educated labor force (% of total) of Hong Kong in 2009 to that in 2013?
Provide a succinct answer. 0.85. What is the ratio of the Educated labor force (% of total) of Europe(all income levels) in 2010 to that in 2011?
Give a very brief answer. 0.98. What is the ratio of the Educated labor force (% of total) in High income in 2010 to that in 2011?
Offer a terse response. 0.98. What is the ratio of the Educated labor force (% of total) in Egypt, Arab Rep. in 2010 to that in 2011?
Ensure brevity in your answer.  0.98. What is the ratio of the Educated labor force (% of total) in Hong Kong in 2010 to that in 2011?
Your answer should be compact. 0.92. What is the ratio of the Educated labor force (% of total) in Europe(all income levels) in 2010 to that in 2012?
Make the answer very short. 0.96. What is the ratio of the Educated labor force (% of total) in High income in 2010 to that in 2012?
Ensure brevity in your answer.  0.97. What is the ratio of the Educated labor force (% of total) of Egypt, Arab Rep. in 2010 to that in 2012?
Provide a succinct answer. 0.95. What is the ratio of the Educated labor force (% of total) of Hong Kong in 2010 to that in 2012?
Your answer should be very brief. 0.93. What is the ratio of the Educated labor force (% of total) in Europe(all income levels) in 2010 to that in 2013?
Ensure brevity in your answer.  0.93. What is the ratio of the Educated labor force (% of total) in High income in 2010 to that in 2013?
Offer a very short reply. 0.94. What is the ratio of the Educated labor force (% of total) in Egypt, Arab Rep. in 2010 to that in 2013?
Ensure brevity in your answer.  1.01. What is the ratio of the Educated labor force (% of total) of Hong Kong in 2010 to that in 2013?
Your answer should be very brief. 0.89. What is the ratio of the Educated labor force (% of total) of Europe(all income levels) in 2011 to that in 2012?
Provide a succinct answer. 0.97. What is the ratio of the Educated labor force (% of total) of High income in 2011 to that in 2012?
Give a very brief answer. 0.98. What is the ratio of the Educated labor force (% of total) in Egypt, Arab Rep. in 2011 to that in 2012?
Ensure brevity in your answer.  0.97. What is the ratio of the Educated labor force (% of total) in Europe(all income levels) in 2011 to that in 2013?
Keep it short and to the point. 0.95. What is the ratio of the Educated labor force (% of total) of High income in 2011 to that in 2013?
Give a very brief answer. 0.96. What is the ratio of the Educated labor force (% of total) in Egypt, Arab Rep. in 2011 to that in 2013?
Your response must be concise. 1.03. What is the ratio of the Educated labor force (% of total) in Hong Kong in 2011 to that in 2013?
Your answer should be compact. 0.97. What is the ratio of the Educated labor force (% of total) in Europe(all income levels) in 2012 to that in 2013?
Offer a very short reply. 0.97. What is the ratio of the Educated labor force (% of total) in High income in 2012 to that in 2013?
Your response must be concise. 0.97. What is the ratio of the Educated labor force (% of total) of Egypt, Arab Rep. in 2012 to that in 2013?
Give a very brief answer. 1.05. What is the ratio of the Educated labor force (% of total) of Hong Kong in 2012 to that in 2013?
Keep it short and to the point. 0.96. What is the difference between the highest and the second highest Educated labor force (% of total) in Europe(all income levels)?
Ensure brevity in your answer.  1.01. What is the difference between the highest and the second highest Educated labor force (% of total) of High income?
Provide a short and direct response. 1.05. What is the difference between the highest and the second highest Educated labor force (% of total) of Hong Kong?
Offer a terse response. 0.3. What is the difference between the highest and the lowest Educated labor force (% of total) of Europe(all income levels)?
Offer a terse response. 3.7. What is the difference between the highest and the lowest Educated labor force (% of total) of High income?
Provide a short and direct response. 3. What is the difference between the highest and the lowest Educated labor force (% of total) of Hong Kong?
Your answer should be compact. 4.1. 